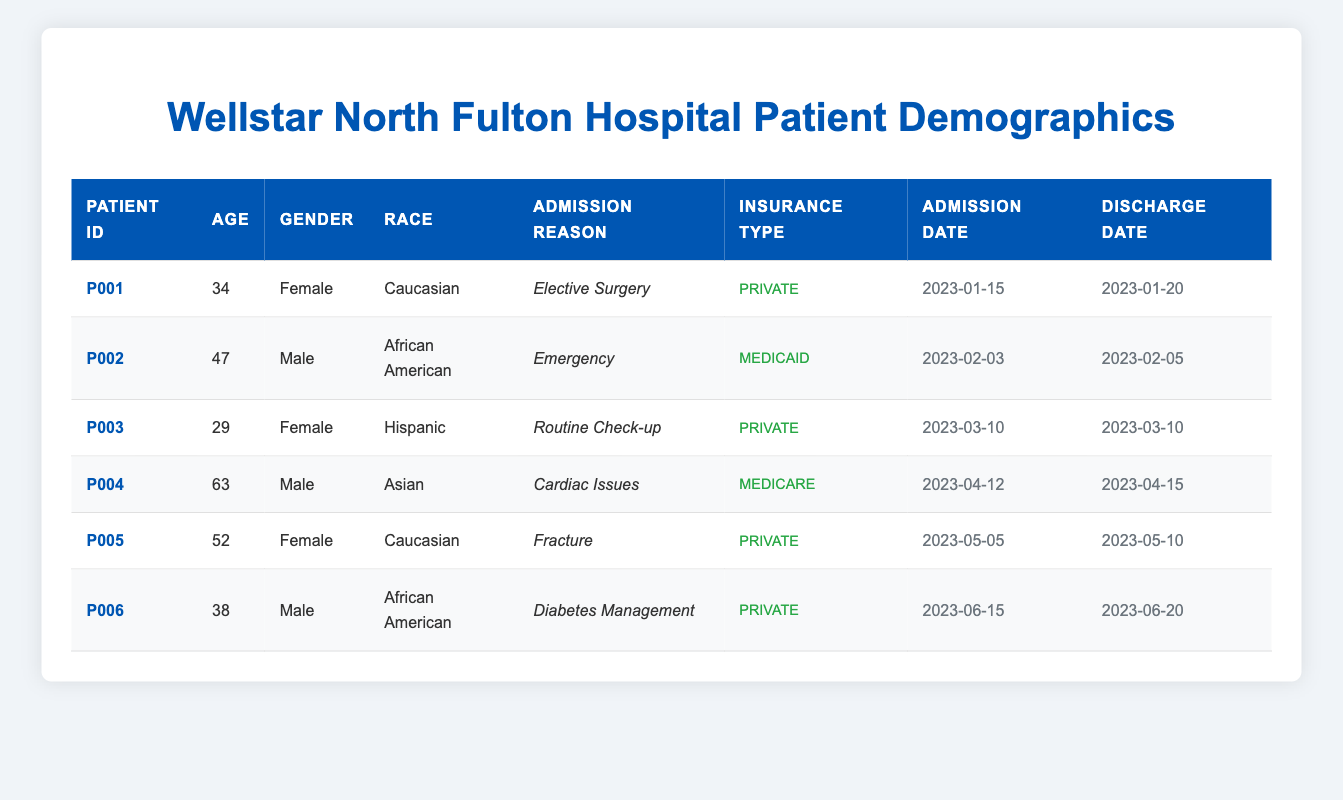What is the age of the oldest patient admitted to Wellstar North Fulton Hospital? The oldest patient in the table is P004, who is 63 years old. You can see the ages listed in the second column, and sorting through them, 63 is the highest value.
Answer: 63 How many female patients were treated at Wellstar North Fulton Hospital? There are three female patients in the table: P001, P003, and P005. By counting the occurrences of "Female" in the gender column, we confirm there are three.
Answer: 3 What is the admission reason for patient P006? The admission reason is listed in the fifth column, where for patient P006, it states "Diabetes Management." This can be read directly from the table.
Answer: Diabetes Management Which patient has the longest hospital stay? Patient P004 has a stay from April 12, 2023, to April 15, 2023, totaling 3 days, while the others have shorter stays. By looking at the admission and discharge dates and calculating the total for each patient, P004 has the longest duration.
Answer: P004 Is there any patient who was discharged on the same day they were admitted? Yes, patient P003 was admitted and discharged on the same day, March 10, 2023, as indicated by the same date in the admission and discharge columns.
Answer: Yes What is the average age of male patients treated at the hospital? The ages of male patients P002, P004, and P006 are 47, 63, and 38, respectively. To calculate the average: (47 + 63 + 38) / 3 = 48. This involves summing the ages and dividing by the number of male patients.
Answer: 48 Which race has the most representation among the patients? In the race column, the breakdown shows two Caucasian, two African American, one Hispanic, and one Asian. By counting these occurrences, the races with the highest representation are Caucasian and African American, each with two patients.
Answer: Caucasian and African American What type of insurance does patient P004 have? Looking at the insurance type column for patient P004, it states "Medicare." This can be checked in the relevant row to find the type associated with that patient ID.
Answer: Medicare 